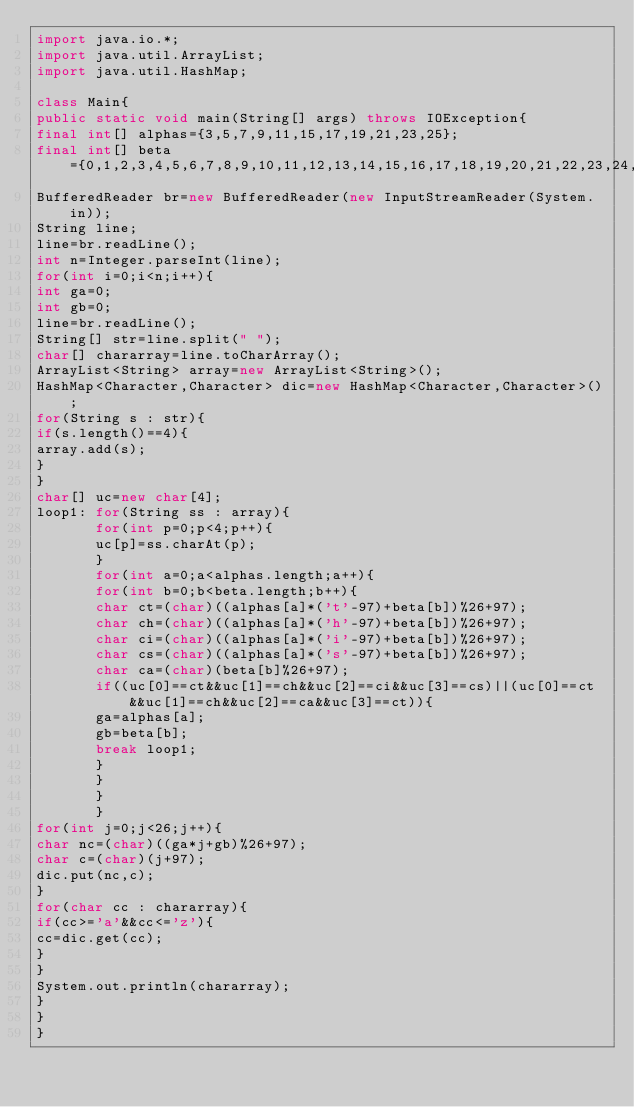<code> <loc_0><loc_0><loc_500><loc_500><_Java_>import java.io.*;
import java.util.ArrayList;
import java.util.HashMap;

class Main{
public static void main(String[] args) throws IOException{
final int[] alphas={3,5,7,9,11,15,17,19,21,23,25};
final int[] beta={0,1,2,3,4,5,6,7,8,9,10,11,12,13,14,15,16,17,18,19,20,21,22,23,24,25};
BufferedReader br=new BufferedReader(new InputStreamReader(System.in));
String line;
line=br.readLine();
int n=Integer.parseInt(line);
for(int i=0;i<n;i++){
int ga=0;
int gb=0;
line=br.readLine();
String[] str=line.split(" ");
char[] chararray=line.toCharArray();
ArrayList<String> array=new ArrayList<String>();
HashMap<Character,Character> dic=new HashMap<Character,Character>();
for(String s : str){
if(s.length()==4){
array.add(s);
}
}
char[] uc=new char[4];
loop1: for(String ss : array){
       for(int p=0;p<4;p++){
       uc[p]=ss.charAt(p);
       }
       for(int a=0;a<alphas.length;a++){
       for(int b=0;b<beta.length;b++){
       char ct=(char)((alphas[a]*('t'-97)+beta[b])%26+97);
       char ch=(char)((alphas[a]*('h'-97)+beta[b])%26+97);
       char ci=(char)((alphas[a]*('i'-97)+beta[b])%26+97);
       char cs=(char)((alphas[a]*('s'-97)+beta[b])%26+97);
       char ca=(char)(beta[b]%26+97);
       if((uc[0]==ct&&uc[1]==ch&&uc[2]==ci&&uc[3]==cs)||(uc[0]==ct&&uc[1]==ch&&uc[2]==ca&&uc[3]==ct)){
       ga=alphas[a];
       gb=beta[b];
       break loop1;
       }
       }
       }
       }
for(int j=0;j<26;j++){
char nc=(char)((ga*j+gb)%26+97);
char c=(char)(j+97);
dic.put(nc,c);
}
for(char cc : chararray){
if(cc>='a'&&cc<='z'){
cc=dic.get(cc);
}
}
System.out.println(chararray);
}
}
}</code> 